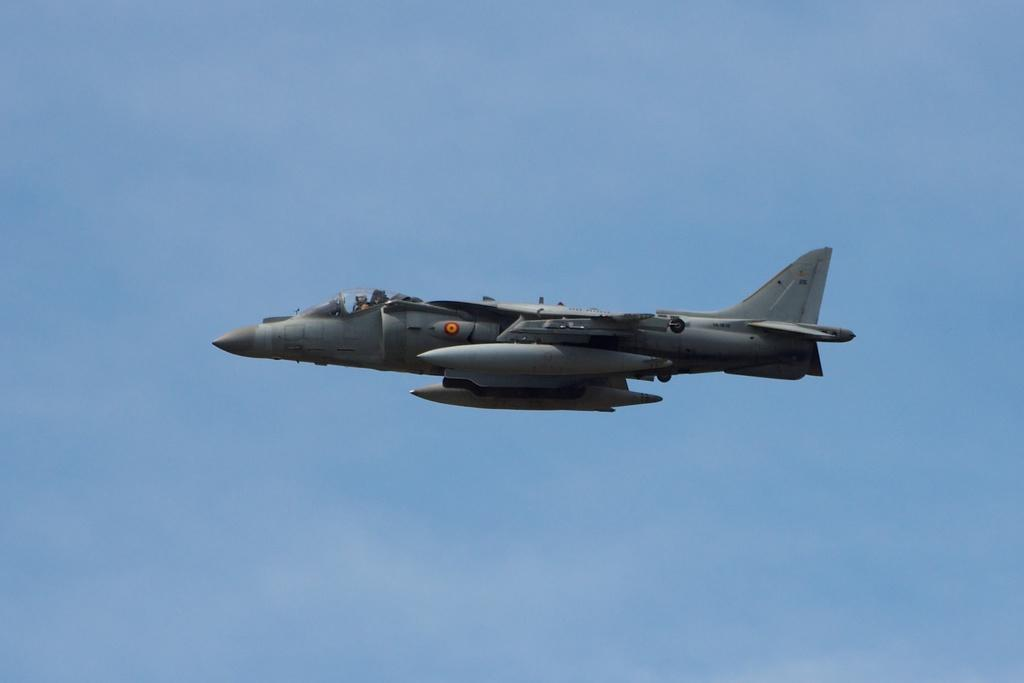What is the color of the sky in the image? The sky in the image is clear and blue. What is the person in the image doing? There is a person flying an aircraft in the image. What type of chain can be seen connecting the aircraft to the ground in the image? There is no chain connecting the aircraft to the ground in the image. How does the person in the image receive a haircut while flying the aircraft? The person in the image is not receiving a haircut; they are focused on flying the aircraft. 